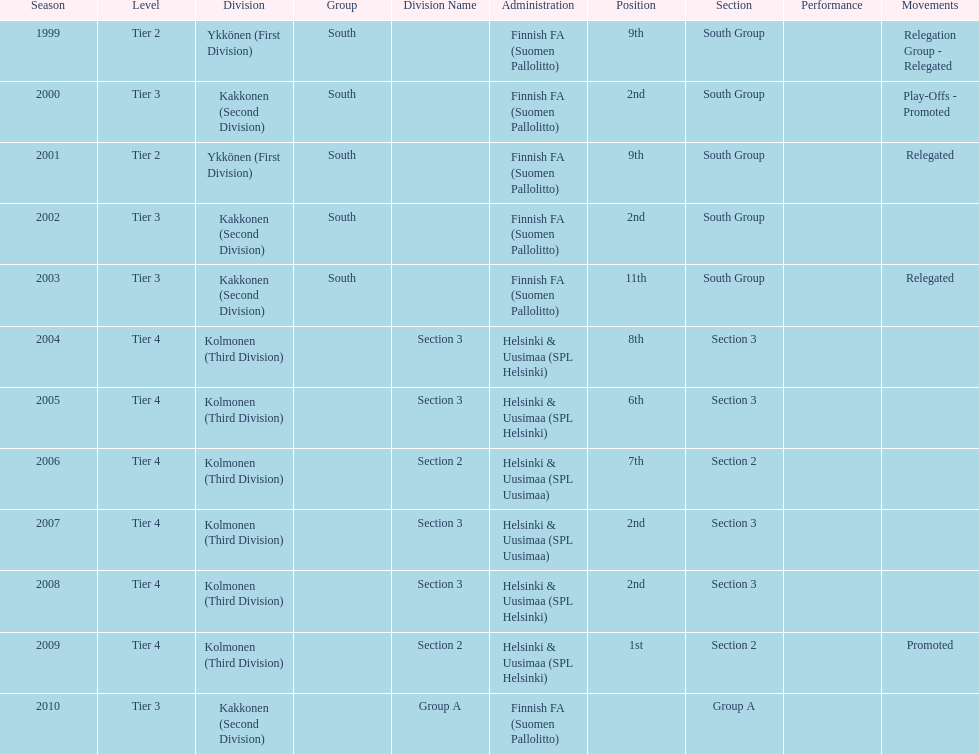How many people were present in section 3 of the third division? 4. 